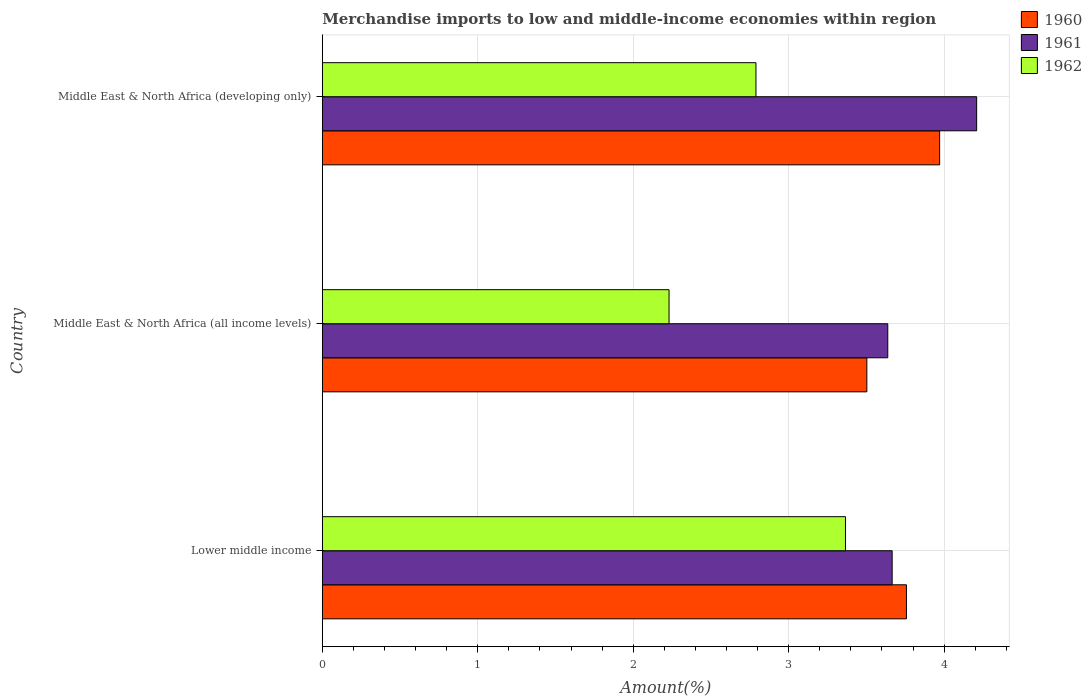How many groups of bars are there?
Ensure brevity in your answer.  3. Are the number of bars per tick equal to the number of legend labels?
Make the answer very short. Yes. How many bars are there on the 2nd tick from the top?
Provide a short and direct response. 3. What is the label of the 1st group of bars from the top?
Your answer should be compact. Middle East & North Africa (developing only). What is the percentage of amount earned from merchandise imports in 1962 in Middle East & North Africa (developing only)?
Your answer should be very brief. 2.79. Across all countries, what is the maximum percentage of amount earned from merchandise imports in 1962?
Your response must be concise. 3.37. Across all countries, what is the minimum percentage of amount earned from merchandise imports in 1960?
Offer a terse response. 3.5. In which country was the percentage of amount earned from merchandise imports in 1961 maximum?
Your response must be concise. Middle East & North Africa (developing only). In which country was the percentage of amount earned from merchandise imports in 1960 minimum?
Make the answer very short. Middle East & North Africa (all income levels). What is the total percentage of amount earned from merchandise imports in 1960 in the graph?
Your answer should be very brief. 11.23. What is the difference between the percentage of amount earned from merchandise imports in 1960 in Lower middle income and that in Middle East & North Africa (all income levels)?
Your answer should be very brief. 0.25. What is the difference between the percentage of amount earned from merchandise imports in 1962 in Lower middle income and the percentage of amount earned from merchandise imports in 1960 in Middle East & North Africa (all income levels)?
Give a very brief answer. -0.14. What is the average percentage of amount earned from merchandise imports in 1961 per country?
Your answer should be compact. 3.84. What is the difference between the percentage of amount earned from merchandise imports in 1962 and percentage of amount earned from merchandise imports in 1961 in Middle East & North Africa (all income levels)?
Provide a succinct answer. -1.41. In how many countries, is the percentage of amount earned from merchandise imports in 1962 greater than 3.4 %?
Offer a terse response. 0. What is the ratio of the percentage of amount earned from merchandise imports in 1961 in Lower middle income to that in Middle East & North Africa (developing only)?
Offer a very short reply. 0.87. Is the percentage of amount earned from merchandise imports in 1960 in Middle East & North Africa (all income levels) less than that in Middle East & North Africa (developing only)?
Ensure brevity in your answer.  Yes. What is the difference between the highest and the second highest percentage of amount earned from merchandise imports in 1961?
Keep it short and to the point. 0.54. What is the difference between the highest and the lowest percentage of amount earned from merchandise imports in 1960?
Make the answer very short. 0.47. Is the sum of the percentage of amount earned from merchandise imports in 1961 in Lower middle income and Middle East & North Africa (developing only) greater than the maximum percentage of amount earned from merchandise imports in 1962 across all countries?
Make the answer very short. Yes. What does the 3rd bar from the top in Middle East & North Africa (developing only) represents?
Your answer should be very brief. 1960. Are all the bars in the graph horizontal?
Ensure brevity in your answer.  Yes. How many countries are there in the graph?
Your response must be concise. 3. What is the difference between two consecutive major ticks on the X-axis?
Provide a succinct answer. 1. Are the values on the major ticks of X-axis written in scientific E-notation?
Offer a terse response. No. Does the graph contain any zero values?
Offer a terse response. No. Does the graph contain grids?
Provide a short and direct response. Yes. How are the legend labels stacked?
Make the answer very short. Vertical. What is the title of the graph?
Provide a short and direct response. Merchandise imports to low and middle-income economies within region. What is the label or title of the X-axis?
Offer a terse response. Amount(%). What is the Amount(%) in 1960 in Lower middle income?
Offer a terse response. 3.76. What is the Amount(%) of 1961 in Lower middle income?
Offer a very short reply. 3.67. What is the Amount(%) in 1962 in Lower middle income?
Offer a very short reply. 3.37. What is the Amount(%) of 1960 in Middle East & North Africa (all income levels)?
Provide a succinct answer. 3.5. What is the Amount(%) of 1961 in Middle East & North Africa (all income levels)?
Make the answer very short. 3.64. What is the Amount(%) in 1962 in Middle East & North Africa (all income levels)?
Keep it short and to the point. 2.23. What is the Amount(%) of 1960 in Middle East & North Africa (developing only)?
Your answer should be compact. 3.97. What is the Amount(%) of 1961 in Middle East & North Africa (developing only)?
Keep it short and to the point. 4.21. What is the Amount(%) of 1962 in Middle East & North Africa (developing only)?
Your answer should be very brief. 2.79. Across all countries, what is the maximum Amount(%) in 1960?
Provide a short and direct response. 3.97. Across all countries, what is the maximum Amount(%) in 1961?
Make the answer very short. 4.21. Across all countries, what is the maximum Amount(%) of 1962?
Make the answer very short. 3.37. Across all countries, what is the minimum Amount(%) of 1960?
Offer a terse response. 3.5. Across all countries, what is the minimum Amount(%) in 1961?
Your response must be concise. 3.64. Across all countries, what is the minimum Amount(%) of 1962?
Provide a succinct answer. 2.23. What is the total Amount(%) of 1960 in the graph?
Provide a short and direct response. 11.23. What is the total Amount(%) in 1961 in the graph?
Make the answer very short. 11.51. What is the total Amount(%) of 1962 in the graph?
Your answer should be compact. 8.38. What is the difference between the Amount(%) in 1960 in Lower middle income and that in Middle East & North Africa (all income levels)?
Offer a terse response. 0.25. What is the difference between the Amount(%) in 1961 in Lower middle income and that in Middle East & North Africa (all income levels)?
Give a very brief answer. 0.03. What is the difference between the Amount(%) in 1962 in Lower middle income and that in Middle East & North Africa (all income levels)?
Keep it short and to the point. 1.14. What is the difference between the Amount(%) in 1960 in Lower middle income and that in Middle East & North Africa (developing only)?
Provide a succinct answer. -0.21. What is the difference between the Amount(%) of 1961 in Lower middle income and that in Middle East & North Africa (developing only)?
Your response must be concise. -0.54. What is the difference between the Amount(%) in 1962 in Lower middle income and that in Middle East & North Africa (developing only)?
Make the answer very short. 0.58. What is the difference between the Amount(%) of 1960 in Middle East & North Africa (all income levels) and that in Middle East & North Africa (developing only)?
Your answer should be very brief. -0.47. What is the difference between the Amount(%) of 1961 in Middle East & North Africa (all income levels) and that in Middle East & North Africa (developing only)?
Provide a succinct answer. -0.57. What is the difference between the Amount(%) in 1962 in Middle East & North Africa (all income levels) and that in Middle East & North Africa (developing only)?
Your response must be concise. -0.56. What is the difference between the Amount(%) of 1960 in Lower middle income and the Amount(%) of 1961 in Middle East & North Africa (all income levels)?
Your response must be concise. 0.12. What is the difference between the Amount(%) of 1960 in Lower middle income and the Amount(%) of 1962 in Middle East & North Africa (all income levels)?
Give a very brief answer. 1.53. What is the difference between the Amount(%) in 1961 in Lower middle income and the Amount(%) in 1962 in Middle East & North Africa (all income levels)?
Make the answer very short. 1.44. What is the difference between the Amount(%) in 1960 in Lower middle income and the Amount(%) in 1961 in Middle East & North Africa (developing only)?
Your answer should be very brief. -0.45. What is the difference between the Amount(%) of 1960 in Lower middle income and the Amount(%) of 1962 in Middle East & North Africa (developing only)?
Your answer should be very brief. 0.97. What is the difference between the Amount(%) in 1961 in Lower middle income and the Amount(%) in 1962 in Middle East & North Africa (developing only)?
Your response must be concise. 0.88. What is the difference between the Amount(%) in 1960 in Middle East & North Africa (all income levels) and the Amount(%) in 1961 in Middle East & North Africa (developing only)?
Provide a short and direct response. -0.71. What is the difference between the Amount(%) in 1960 in Middle East & North Africa (all income levels) and the Amount(%) in 1962 in Middle East & North Africa (developing only)?
Make the answer very short. 0.71. What is the difference between the Amount(%) in 1961 in Middle East & North Africa (all income levels) and the Amount(%) in 1962 in Middle East & North Africa (developing only)?
Make the answer very short. 0.85. What is the average Amount(%) in 1960 per country?
Provide a succinct answer. 3.74. What is the average Amount(%) in 1961 per country?
Your answer should be compact. 3.84. What is the average Amount(%) in 1962 per country?
Offer a very short reply. 2.79. What is the difference between the Amount(%) in 1960 and Amount(%) in 1961 in Lower middle income?
Offer a terse response. 0.09. What is the difference between the Amount(%) in 1960 and Amount(%) in 1962 in Lower middle income?
Make the answer very short. 0.39. What is the difference between the Amount(%) of 1961 and Amount(%) of 1962 in Lower middle income?
Provide a succinct answer. 0.3. What is the difference between the Amount(%) in 1960 and Amount(%) in 1961 in Middle East & North Africa (all income levels)?
Ensure brevity in your answer.  -0.13. What is the difference between the Amount(%) in 1960 and Amount(%) in 1962 in Middle East & North Africa (all income levels)?
Offer a very short reply. 1.27. What is the difference between the Amount(%) in 1961 and Amount(%) in 1962 in Middle East & North Africa (all income levels)?
Make the answer very short. 1.41. What is the difference between the Amount(%) of 1960 and Amount(%) of 1961 in Middle East & North Africa (developing only)?
Your answer should be very brief. -0.24. What is the difference between the Amount(%) in 1960 and Amount(%) in 1962 in Middle East & North Africa (developing only)?
Give a very brief answer. 1.18. What is the difference between the Amount(%) of 1961 and Amount(%) of 1962 in Middle East & North Africa (developing only)?
Your answer should be very brief. 1.42. What is the ratio of the Amount(%) of 1960 in Lower middle income to that in Middle East & North Africa (all income levels)?
Offer a terse response. 1.07. What is the ratio of the Amount(%) of 1962 in Lower middle income to that in Middle East & North Africa (all income levels)?
Provide a succinct answer. 1.51. What is the ratio of the Amount(%) of 1960 in Lower middle income to that in Middle East & North Africa (developing only)?
Offer a terse response. 0.95. What is the ratio of the Amount(%) of 1961 in Lower middle income to that in Middle East & North Africa (developing only)?
Provide a succinct answer. 0.87. What is the ratio of the Amount(%) in 1962 in Lower middle income to that in Middle East & North Africa (developing only)?
Provide a succinct answer. 1.21. What is the ratio of the Amount(%) in 1960 in Middle East & North Africa (all income levels) to that in Middle East & North Africa (developing only)?
Ensure brevity in your answer.  0.88. What is the ratio of the Amount(%) in 1961 in Middle East & North Africa (all income levels) to that in Middle East & North Africa (developing only)?
Your answer should be compact. 0.86. What is the ratio of the Amount(%) of 1962 in Middle East & North Africa (all income levels) to that in Middle East & North Africa (developing only)?
Your answer should be very brief. 0.8. What is the difference between the highest and the second highest Amount(%) in 1960?
Offer a terse response. 0.21. What is the difference between the highest and the second highest Amount(%) in 1961?
Your answer should be very brief. 0.54. What is the difference between the highest and the second highest Amount(%) in 1962?
Ensure brevity in your answer.  0.58. What is the difference between the highest and the lowest Amount(%) of 1960?
Provide a short and direct response. 0.47. What is the difference between the highest and the lowest Amount(%) in 1961?
Your answer should be very brief. 0.57. What is the difference between the highest and the lowest Amount(%) of 1962?
Your answer should be compact. 1.14. 